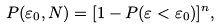<formula> <loc_0><loc_0><loc_500><loc_500>P ( \varepsilon _ { 0 } , N ) = [ 1 - P ( \varepsilon < \varepsilon _ { 0 } ) ] ^ { n } ,</formula> 